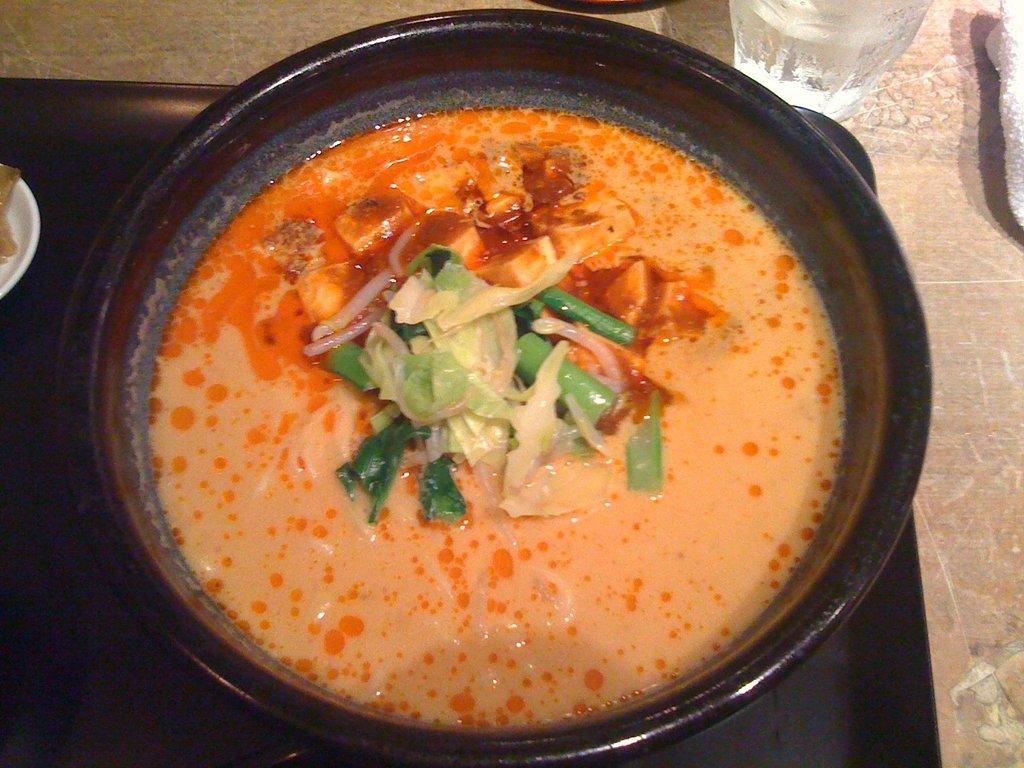What piece of furniture is present in the image? There is a table in the image. What is on the table? There is a serving bowl with food, a glass tumbler, a napkin, and a tray on the table. What might be used for cleaning or wiping in the image? A napkin is present on the table for cleaning or wiping. What type of acoustics can be heard in the image? There is no information about acoustics in the image, as it only shows a table with various items on it. What type of fork is present in the image? There is no fork present in the image; only a serving bowl with food, a glass tumbler, a napkin, and a tray are visible on the table. 